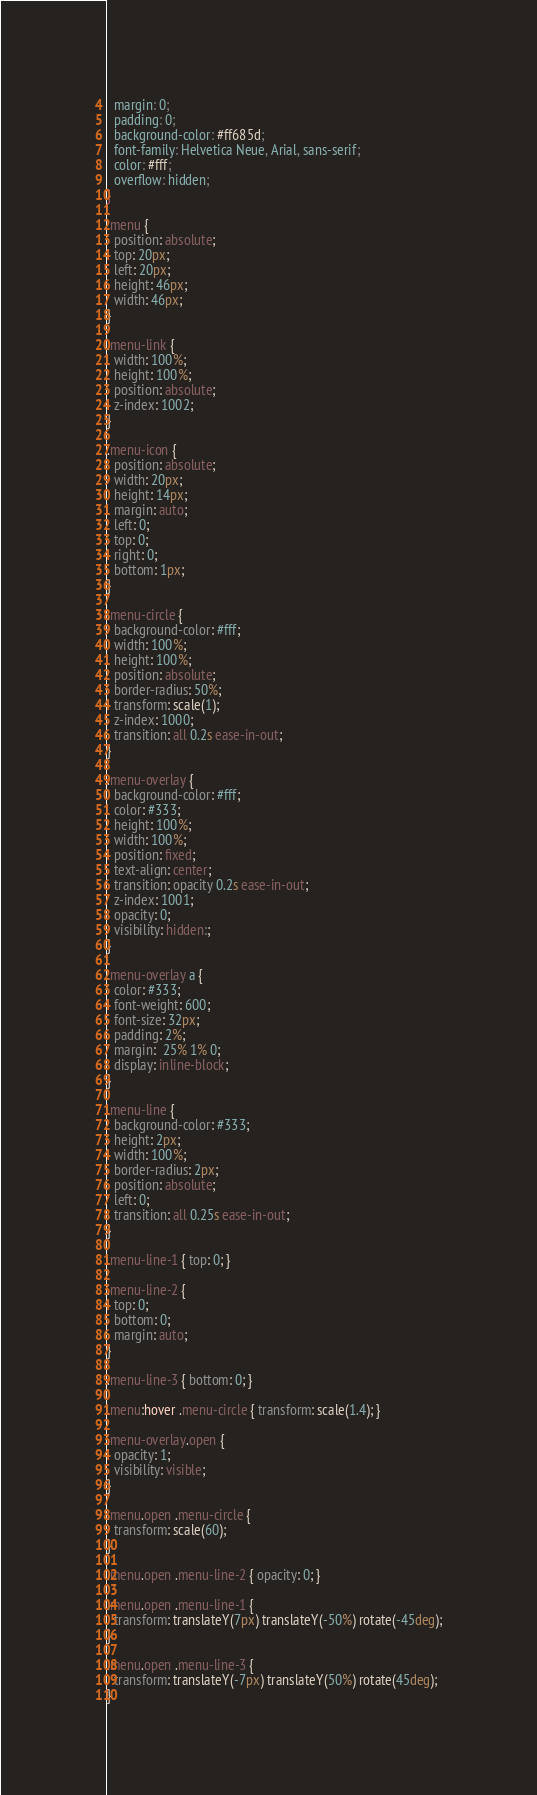<code> <loc_0><loc_0><loc_500><loc_500><_CSS_>  margin: 0;
  padding: 0;
  background-color: #ff685d;
  font-family: Helvetica Neue, Arial, sans-serif;
  color: #fff;
  overflow: hidden;
}

.menu {
  position: absolute;
  top: 20px;
  left: 20px;
  height: 46px;
  width: 46px;
}

.menu-link {
  width: 100%;
  height: 100%;
  position: absolute;
  z-index: 1002;
}

.menu-icon {
  position: absolute;
  width: 20px;
  height: 14px;
  margin: auto;
  left: 0;
  top: 0;
  right: 0;
  bottom: 1px;
}

.menu-circle {
  background-color: #fff;
  width: 100%;
  height: 100%;
  position: absolute;
  border-radius: 50%;
  transform: scale(1);
  z-index: 1000;
  transition: all 0.2s ease-in-out;
}

.menu-overlay {
  background-color: #fff;
  color: #333;
  height: 100%;
  width: 100%;
  position: fixed;
  text-align: center;
  transition: opacity 0.2s ease-in-out;
  z-index: 1001;
  opacity: 0;
  visibility: hidden:;
}

.menu-overlay a {
  color: #333;
  font-weight: 600;
  font-size: 32px;
  padding: 2%;
  margin:  25% 1% 0;
  display: inline-block;
}

.menu-line {
  background-color: #333;
  height: 2px;
  width: 100%;
  border-radius: 2px;
  position: absolute;
  left: 0;
  transition: all 0.25s ease-in-out;
}

.menu-line-1 { top: 0; }

.menu-line-2 {
  top: 0;
  bottom: 0;
  margin: auto;
}

.menu-line-3 { bottom: 0; }

.menu:hover .menu-circle { transform: scale(1.4); }

.menu-overlay.open {
  opacity: 1;
  visibility: visible;
}

.menu.open .menu-circle { 
  transform: scale(60);
}

.menu.open .menu-line-2 { opacity: 0; }

.menu.open .menu-line-1 {
  transform: translateY(7px) translateY(-50%) rotate(-45deg);
}

.menu.open .menu-line-3 {
  transform: translateY(-7px) translateY(50%) rotate(45deg);
}</code> 